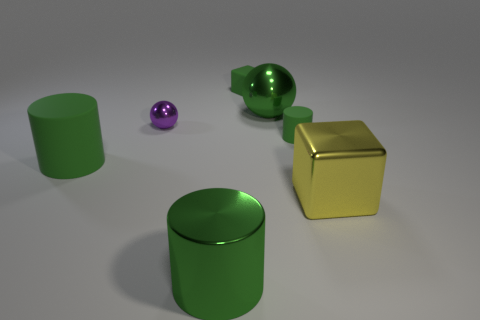Is the color of the big thing behind the large matte cylinder the same as the big cylinder in front of the big metallic block?
Provide a short and direct response. Yes. Is there anything else of the same color as the small block?
Provide a succinct answer. Yes. Are there fewer tiny green matte blocks that are in front of the matte cube than purple metallic balls?
Give a very brief answer. Yes. There is a large metal object that is behind the yellow metallic cube behind the object that is in front of the big metallic cube; what shape is it?
Offer a terse response. Sphere. Do the small metal object and the large matte object have the same shape?
Ensure brevity in your answer.  No. What number of other objects are the same shape as the small purple thing?
Your answer should be very brief. 1. The rubber cylinder that is the same size as the yellow cube is what color?
Keep it short and to the point. Green. Are there the same number of green shiny balls that are left of the large yellow object and small purple spheres?
Provide a succinct answer. Yes. What shape is the large green object that is behind the metal cylinder and to the right of the purple ball?
Make the answer very short. Sphere. Do the green metallic cylinder and the metallic block have the same size?
Your answer should be compact. Yes. 